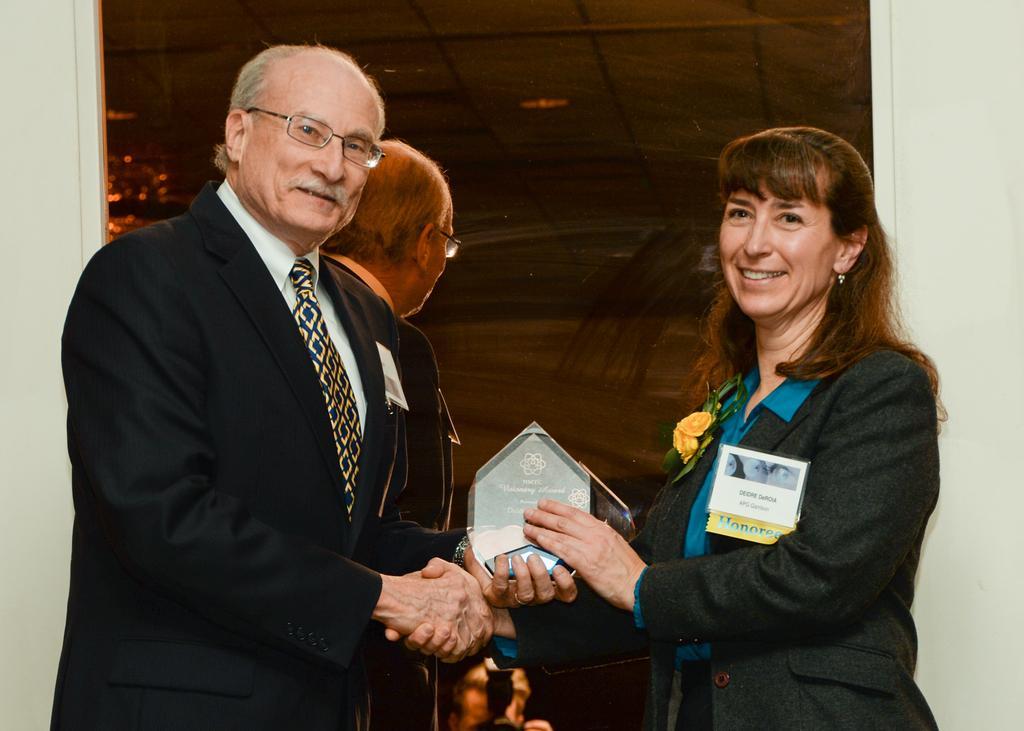Please provide a concise description of this image. In the picture I can see a person wearing black color coat, shirt, tie and spectacles is standing on the left side of the image and a woman wearing blazer is standing on the right side of the image. They both are holding shield and shaking their hands. In the background, I can see the mirror in which I can see the reflection of this man. 